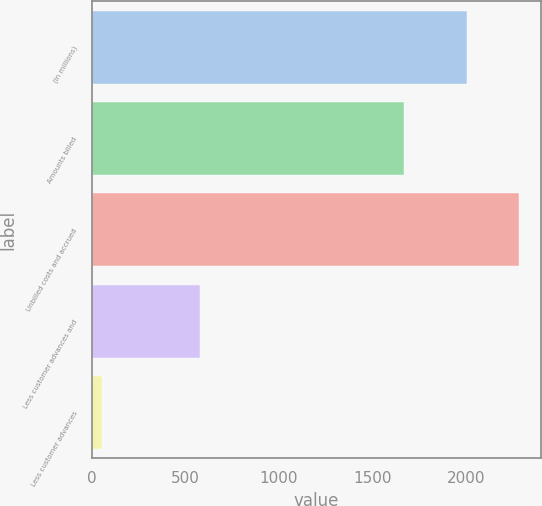Convert chart. <chart><loc_0><loc_0><loc_500><loc_500><bar_chart><fcel>(In millions)<fcel>Amounts billed<fcel>Unbilled costs and accrued<fcel>Less customer advances and<fcel>Less customer advances<nl><fcel>2006<fcel>1671<fcel>2284<fcel>579<fcel>53<nl></chart> 